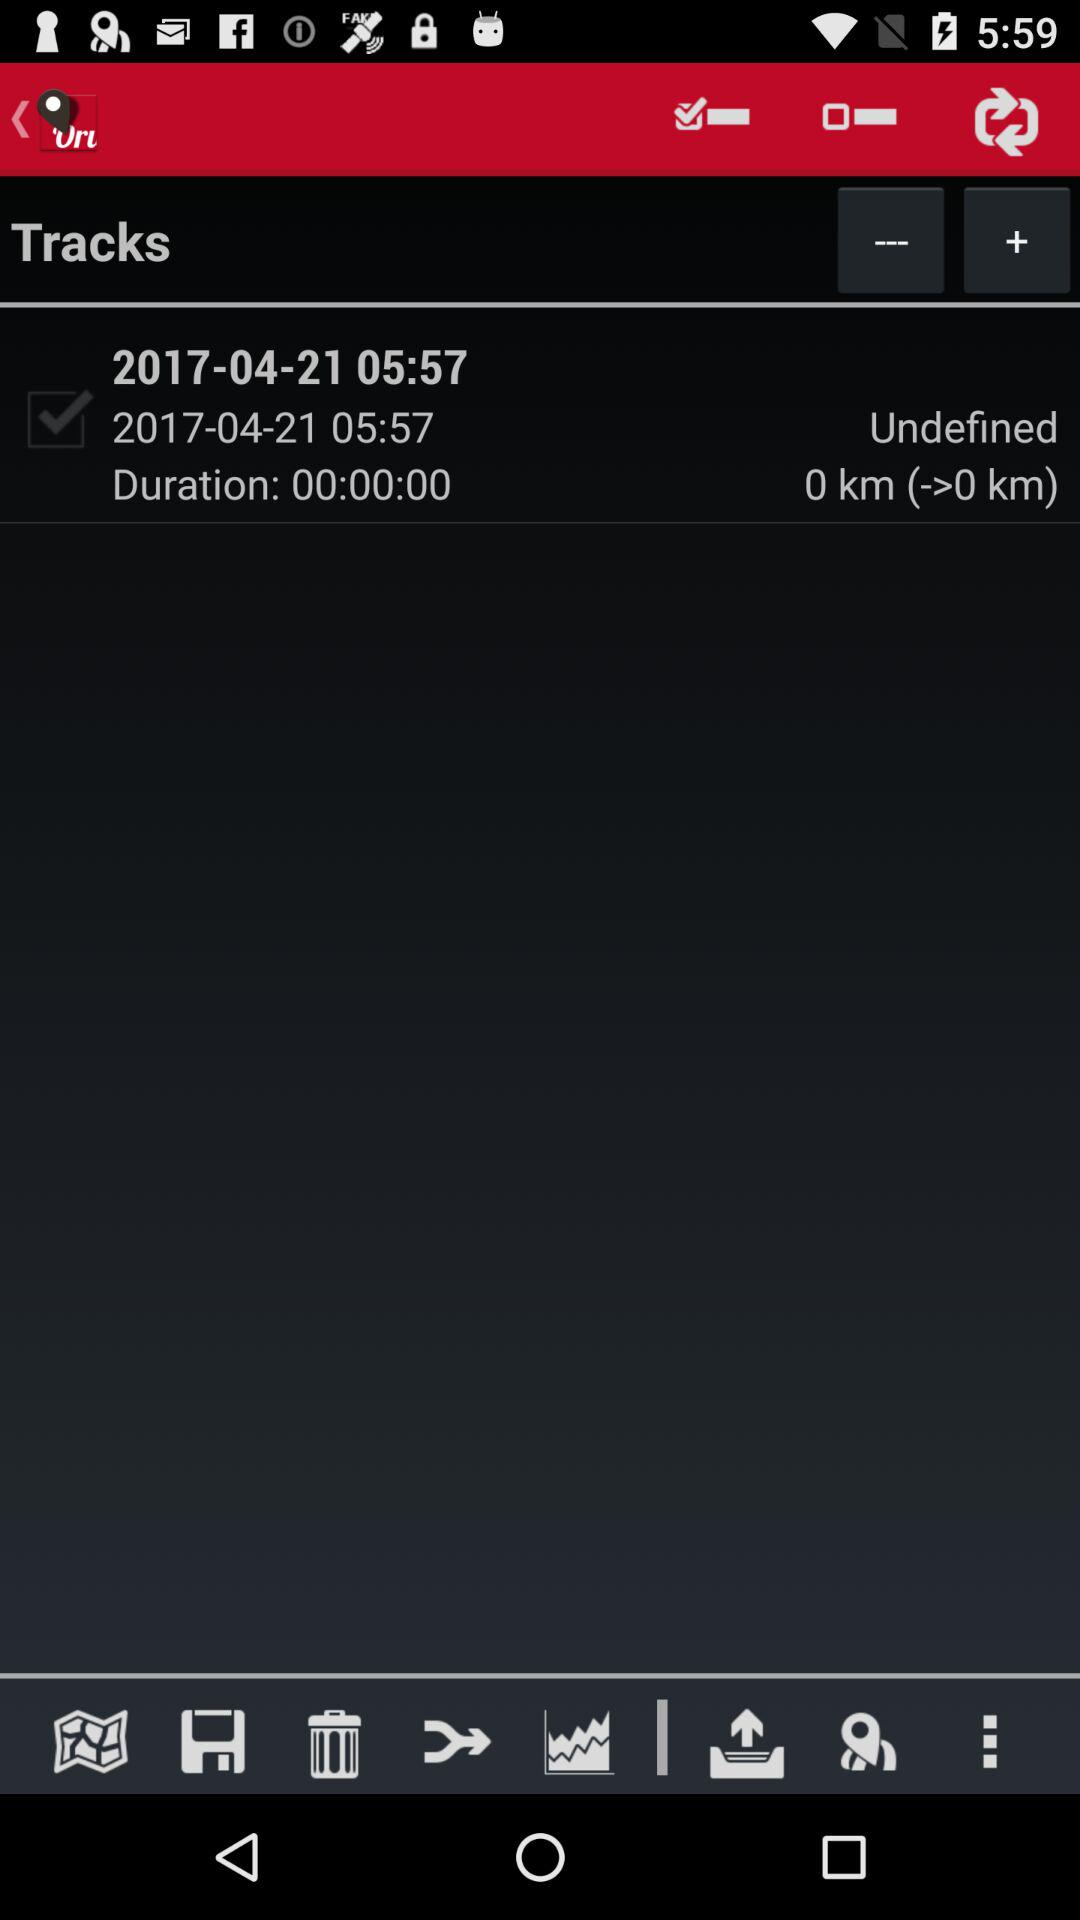What is the duration of the tracks? The duration of the track is 0 seconds. 